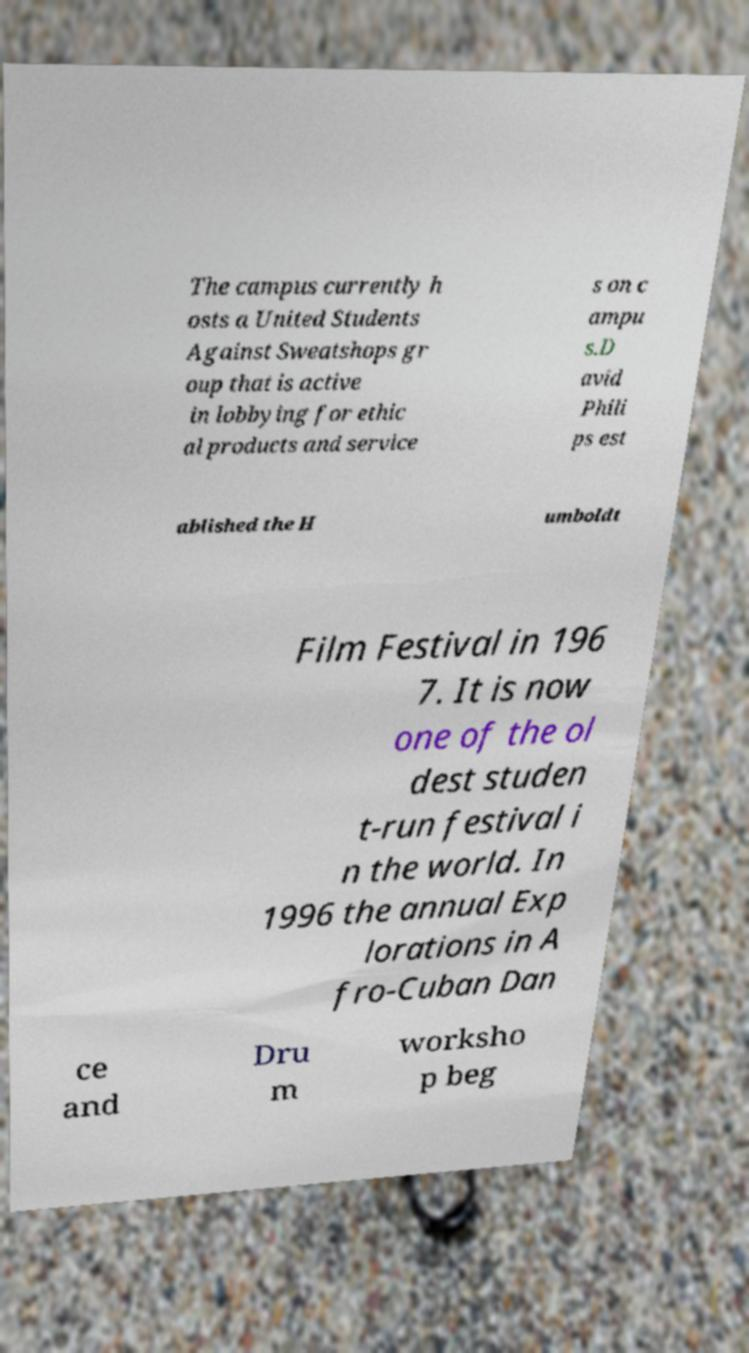Could you assist in decoding the text presented in this image and type it out clearly? The campus currently h osts a United Students Against Sweatshops gr oup that is active in lobbying for ethic al products and service s on c ampu s.D avid Phili ps est ablished the H umboldt Film Festival in 196 7. It is now one of the ol dest studen t-run festival i n the world. In 1996 the annual Exp lorations in A fro-Cuban Dan ce and Dru m worksho p beg 